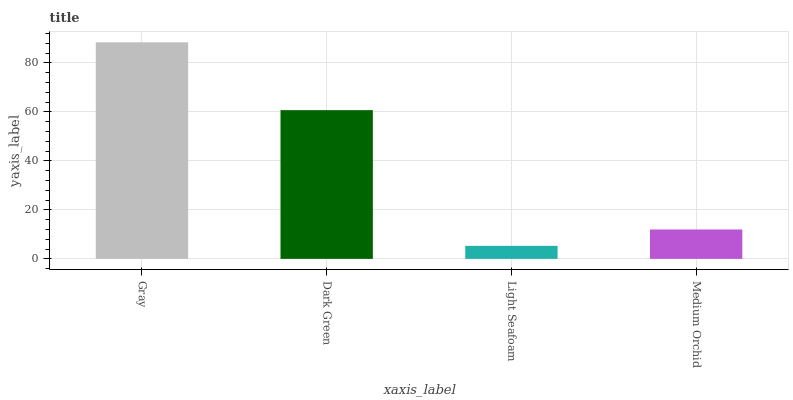Is Light Seafoam the minimum?
Answer yes or no. Yes. Is Gray the maximum?
Answer yes or no. Yes. Is Dark Green the minimum?
Answer yes or no. No. Is Dark Green the maximum?
Answer yes or no. No. Is Gray greater than Dark Green?
Answer yes or no. Yes. Is Dark Green less than Gray?
Answer yes or no. Yes. Is Dark Green greater than Gray?
Answer yes or no. No. Is Gray less than Dark Green?
Answer yes or no. No. Is Dark Green the high median?
Answer yes or no. Yes. Is Medium Orchid the low median?
Answer yes or no. Yes. Is Light Seafoam the high median?
Answer yes or no. No. Is Light Seafoam the low median?
Answer yes or no. No. 